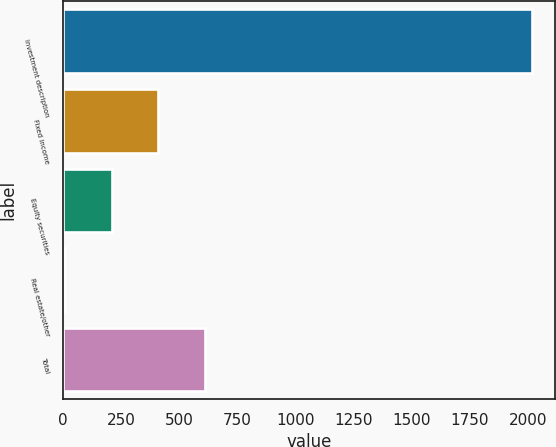Convert chart to OTSL. <chart><loc_0><loc_0><loc_500><loc_500><bar_chart><fcel>Investment description<fcel>Fixed income<fcel>Equity securities<fcel>Real estate/other<fcel>Total<nl><fcel>2015<fcel>409.4<fcel>208.7<fcel>8<fcel>610.1<nl></chart> 